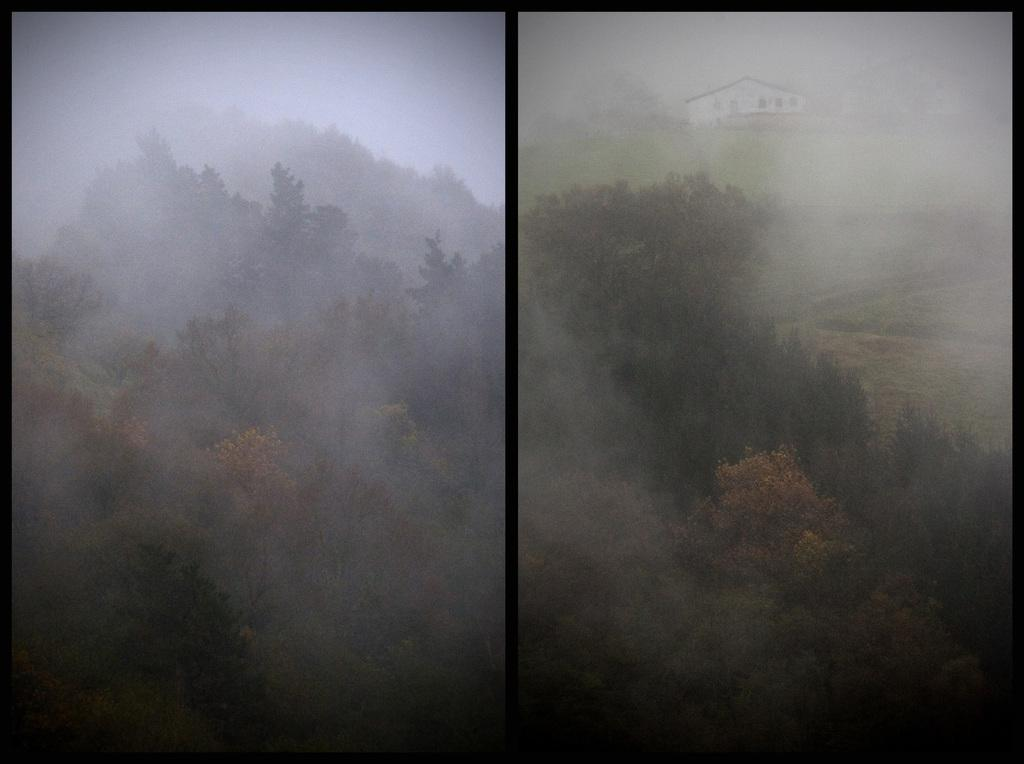What type of composition is the image? The image is a collage of two pictures. What natural elements can be seen in the image? There are trees visible in the image. What man-made structure is present in the image? There is a house in the image. What is the indication of human activity in the image? There is smoke visible in the image, which may suggest a fire or industrial activity. What type of growth is visible on the writer in the image? There is no writer present in the image, so there cannot be any growth visible on them. 